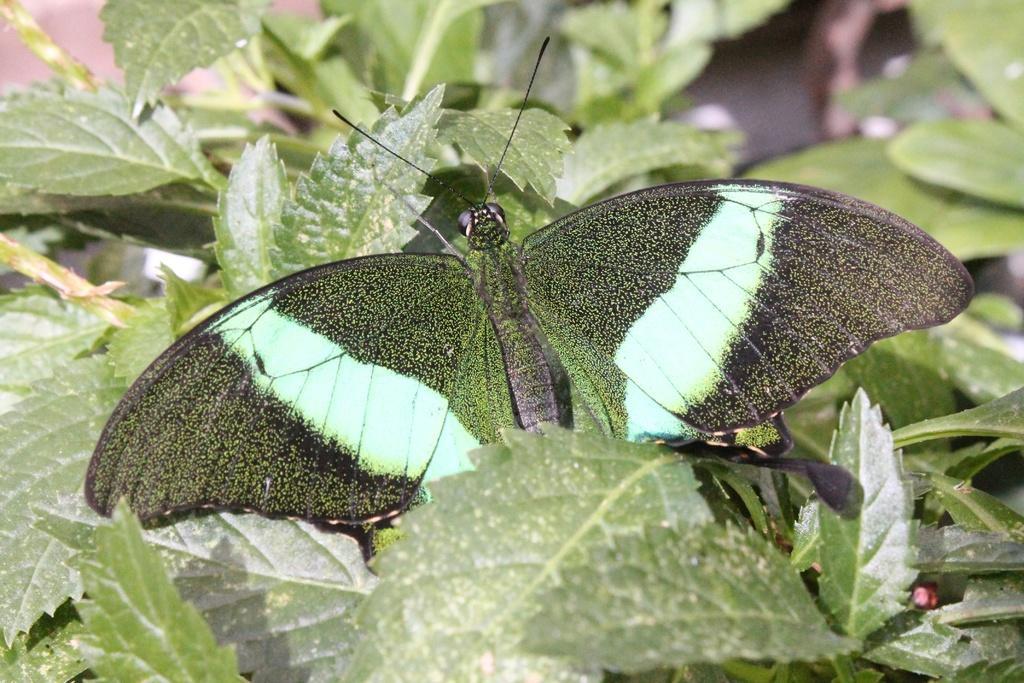In one or two sentences, can you explain what this image depicts? As we can see in the image there are plants and butterfly. 